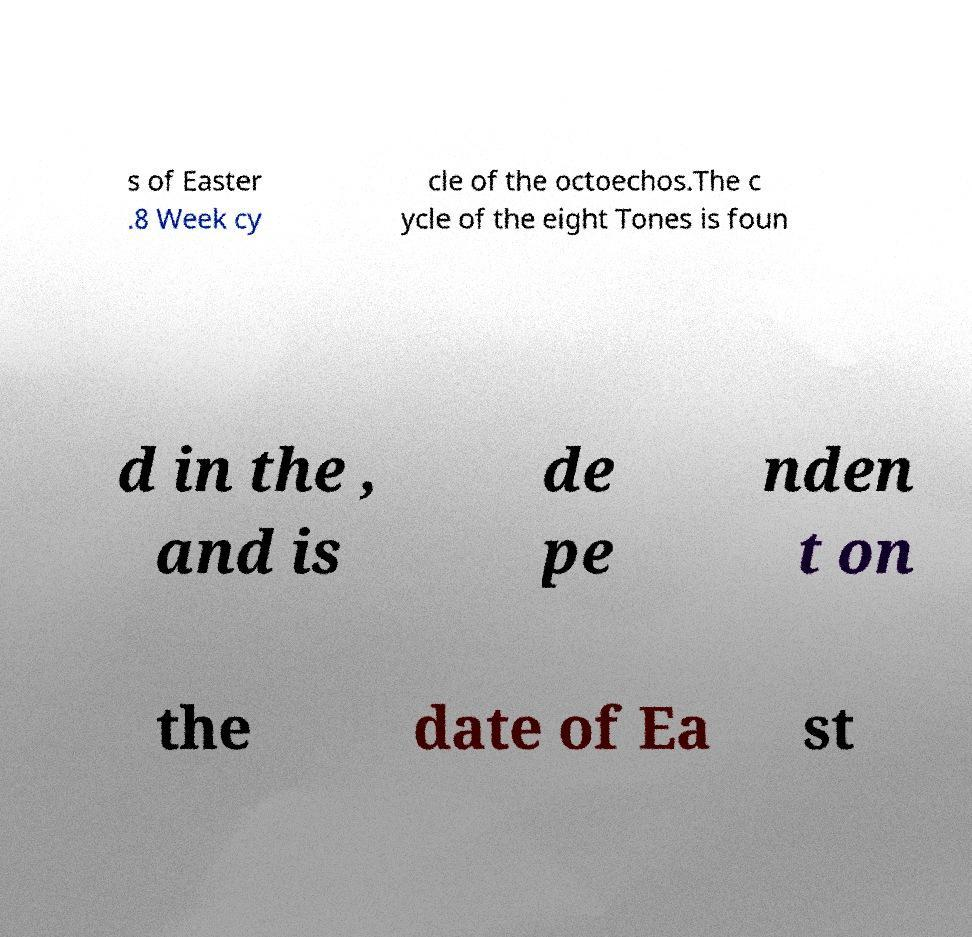I need the written content from this picture converted into text. Can you do that? s of Easter .8 Week cy cle of the octoechos.The c ycle of the eight Tones is foun d in the , and is de pe nden t on the date of Ea st 